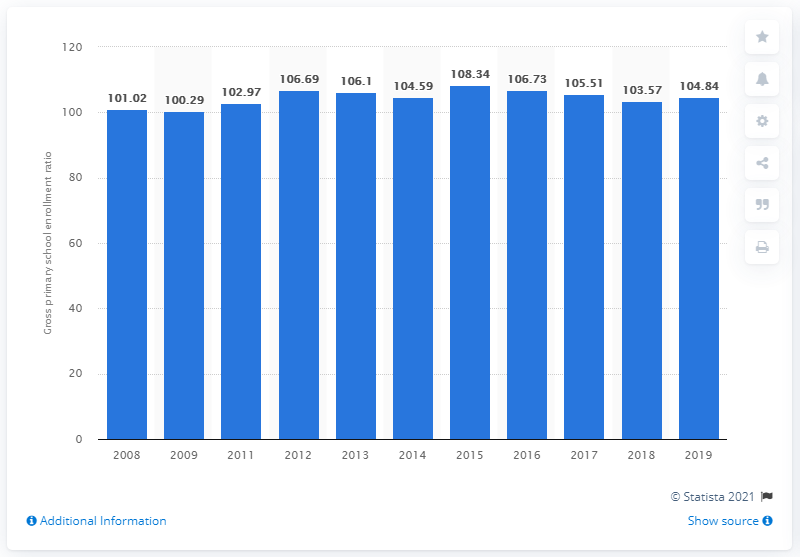Give some essential details in this illustration. In 2019, the gross enrollment ratio for primary school students in Ghana was 104.84, meaning that 104.84% of eligible primary school-aged children were enrolled in school. In 2015, the highest enrollment ratio for primary school students in Ghana was 108.34%. This means that the total number of students enrolled in primary school in Ghana was 108.34% of the total number of eligible students. In 2018, the gross enrollment ratio for primary school students in Ghana was 103.57. 